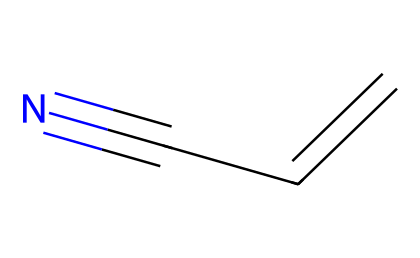What is the name of this chemical? The SMILES representation provided (C=CC#N) corresponds to acrylonitrile, which is a known nitrile.
Answer: acrylonitrile How many carbon atoms are present? The chemical structure C=CC#N contains three carbon atoms (C=C and two Cs from the C#N), counted directly from the SMILES representation.
Answer: three What type of functional group is present in this compound? This compound contains a nitrile functional group, which is indicated by the presence of the carbon triple-bonded to nitrogen (C#N).
Answer: nitrile What is the total number of bonds in the molecule? In acrylonitrile, there are a total of 4 bonds: 1 double bond (C=C) and 1 triple bond (C#N) plus 2 single bonds between the carbon atoms.
Answer: four How many hydrogen atoms are in acrylonitrile? To determine hydrogen atoms: Each carbon forms a total of 4 bonds (octet rule). The ethenyl part (C=CC) has one hydrogen (CHO) and each terminal C has 2 H; thus, there are 3 H in total.
Answer: three What is one industrial application of acrylonitrile? Acrylonitrile is primarily used in the production of polymers and plastics, specifically for creating acrylonitrile-butadiene-styrene (ABS) and other copolymers.
Answer: plastics 